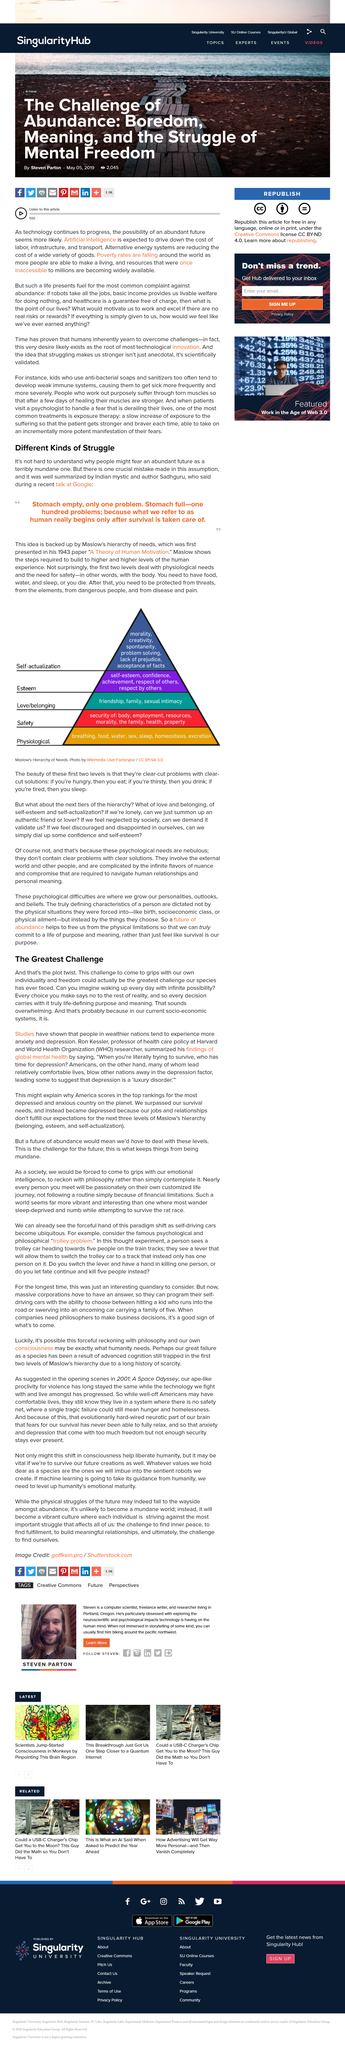Outline some significant characteristics in this image. Every choice you make fundamentally alters the very fabric of reality, as it asserts a definitive 'no' to all other available options. The Greatest Challenge" demands that we come to terms with our individuality and freedom, and embrace the responsibility that comes with them. Steven lives in Portland, Oregon. The first two levels of Maslow's Hierarchy of Needs deal with physiological needs and the need for safety, respectively. Steven is a computer scientist who specializes in the field of computer science. 